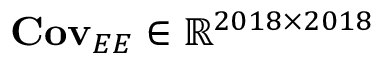Convert formula to latex. <formula><loc_0><loc_0><loc_500><loc_500>{ C o v } _ { E E } \in \mathbb { R } ^ { 2 0 1 8 \times 2 0 1 8 }</formula> 